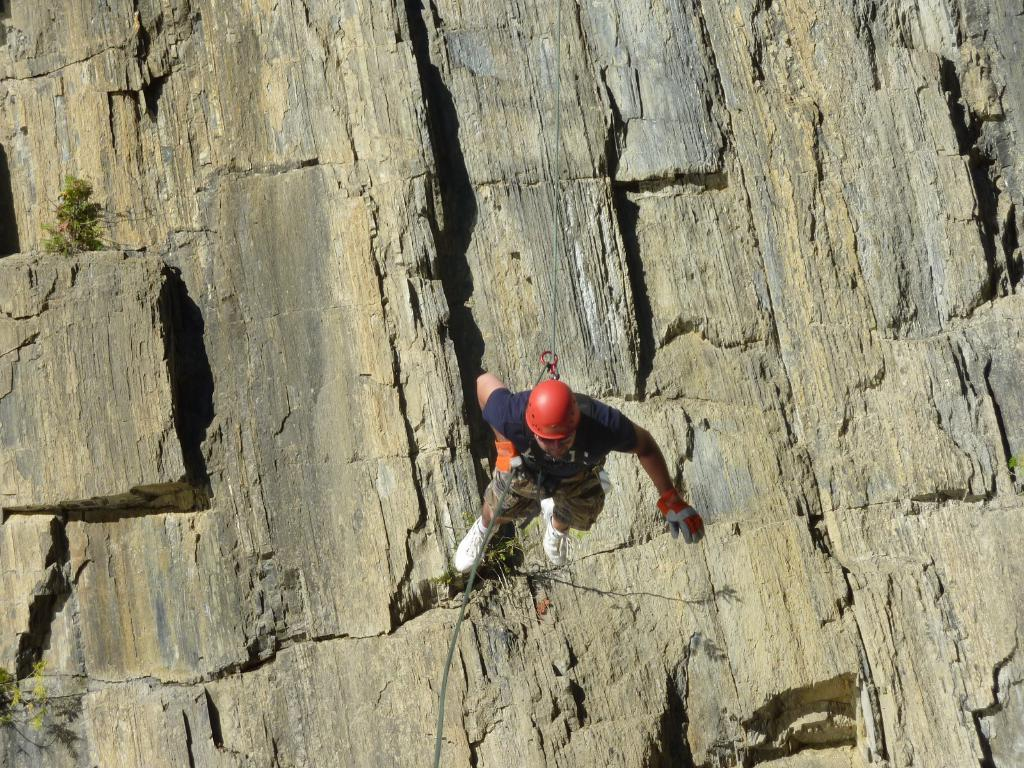What is the main subject of the picture? The main subject of the picture is a man. What is the man doing in the picture? The man is climbing a rock in the picture. Is there any equipment or accessory used by the man in the picture? Yes, a rope is tied to the waist of the man in the picture. What type of insect can be seen crawling on the man's shoulder in the image? There is no insect visible on the man's shoulder in the image. What type of ornament is hanging from the rope in the image? There is no ornament present on the rope in the image. 